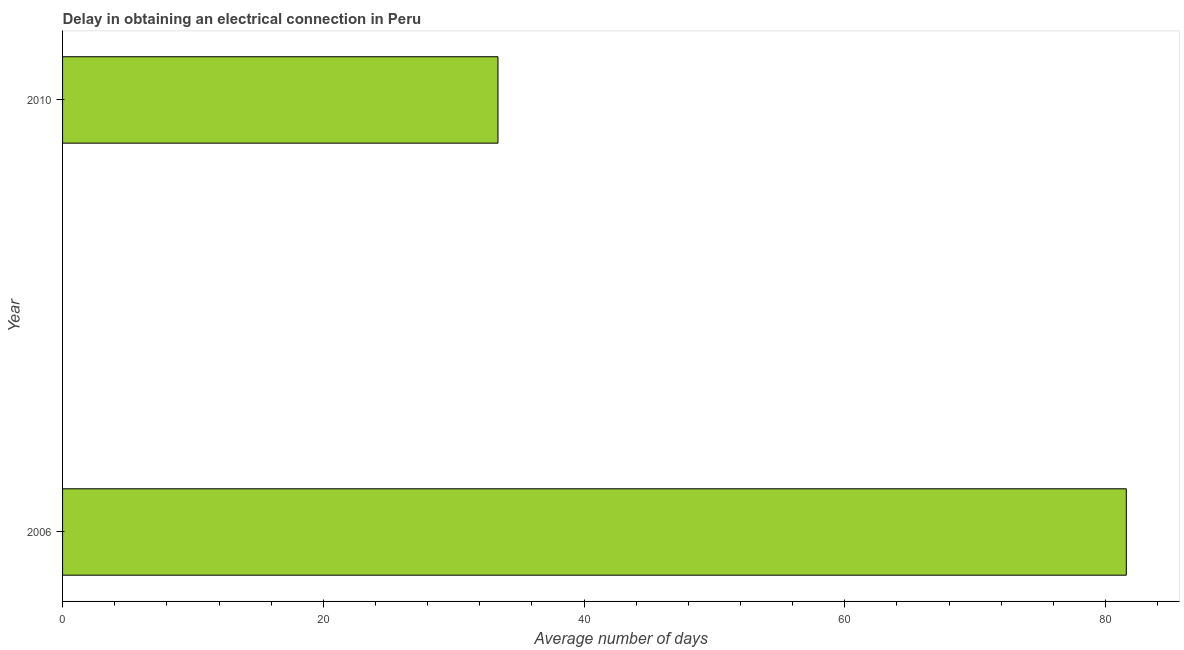Does the graph contain grids?
Keep it short and to the point. No. What is the title of the graph?
Give a very brief answer. Delay in obtaining an electrical connection in Peru. What is the label or title of the X-axis?
Give a very brief answer. Average number of days. What is the label or title of the Y-axis?
Make the answer very short. Year. What is the dalay in electrical connection in 2010?
Your answer should be compact. 33.4. Across all years, what is the maximum dalay in electrical connection?
Provide a succinct answer. 81.6. Across all years, what is the minimum dalay in electrical connection?
Provide a short and direct response. 33.4. What is the sum of the dalay in electrical connection?
Provide a short and direct response. 115. What is the difference between the dalay in electrical connection in 2006 and 2010?
Keep it short and to the point. 48.2. What is the average dalay in electrical connection per year?
Ensure brevity in your answer.  57.5. What is the median dalay in electrical connection?
Offer a terse response. 57.5. Do a majority of the years between 2006 and 2010 (inclusive) have dalay in electrical connection greater than 64 days?
Your answer should be compact. No. What is the ratio of the dalay in electrical connection in 2006 to that in 2010?
Keep it short and to the point. 2.44. Is the dalay in electrical connection in 2006 less than that in 2010?
Keep it short and to the point. No. How many bars are there?
Make the answer very short. 2. Are all the bars in the graph horizontal?
Keep it short and to the point. Yes. How many years are there in the graph?
Your response must be concise. 2. What is the difference between two consecutive major ticks on the X-axis?
Offer a terse response. 20. What is the Average number of days in 2006?
Make the answer very short. 81.6. What is the Average number of days in 2010?
Provide a succinct answer. 33.4. What is the difference between the Average number of days in 2006 and 2010?
Offer a very short reply. 48.2. What is the ratio of the Average number of days in 2006 to that in 2010?
Give a very brief answer. 2.44. 